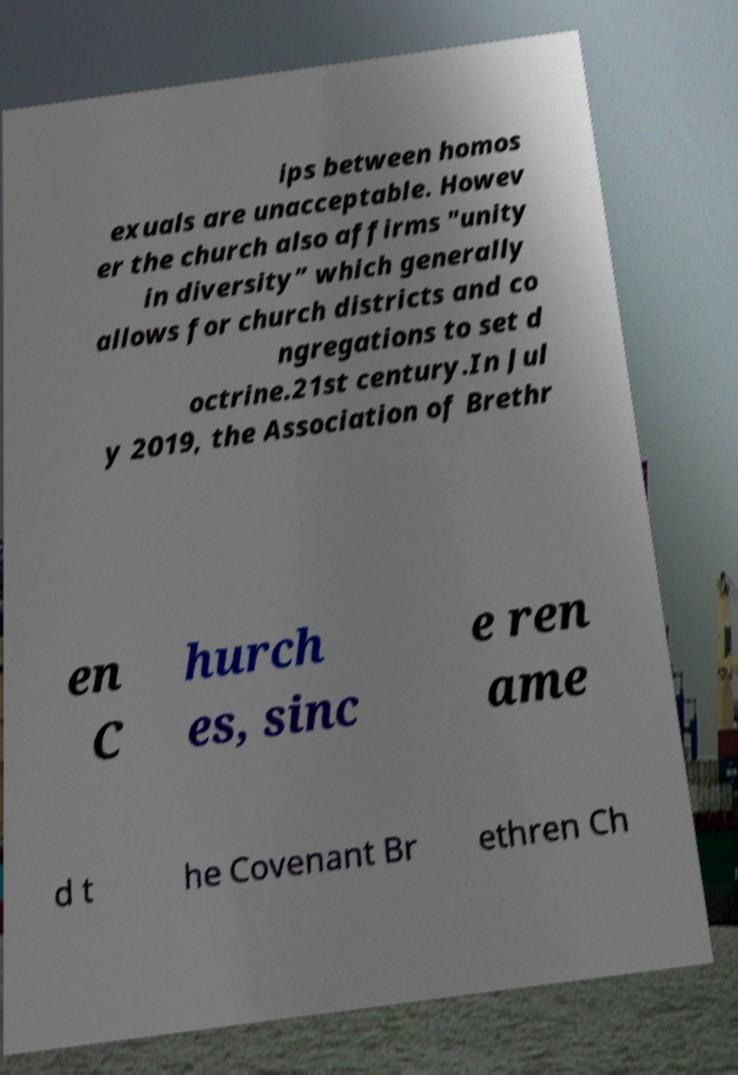There's text embedded in this image that I need extracted. Can you transcribe it verbatim? ips between homos exuals are unacceptable. Howev er the church also affirms "unity in diversity” which generally allows for church districts and co ngregations to set d octrine.21st century.In Jul y 2019, the Association of Brethr en C hurch es, sinc e ren ame d t he Covenant Br ethren Ch 